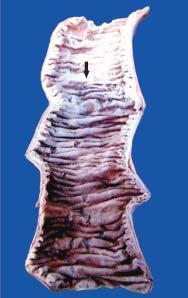s the affected area on right clear-cut?
Answer the question using a single word or phrase. No 